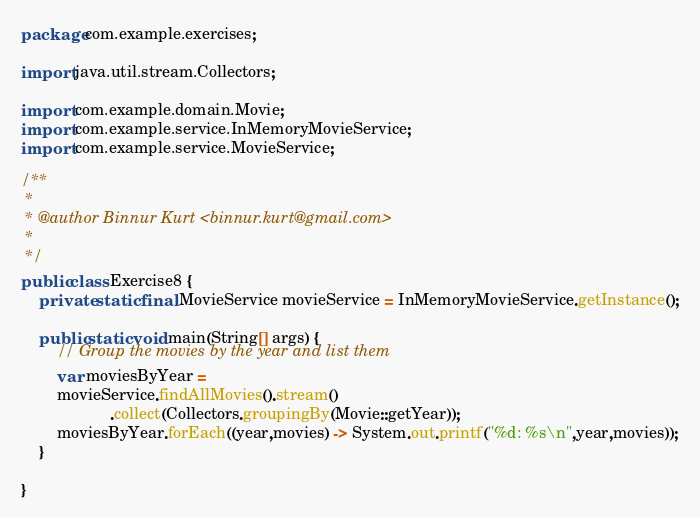<code> <loc_0><loc_0><loc_500><loc_500><_Java_>package com.example.exercises;

import java.util.stream.Collectors;

import com.example.domain.Movie;
import com.example.service.InMemoryMovieService;
import com.example.service.MovieService;

/**
 * 
 * @author Binnur Kurt <binnur.kurt@gmail.com>
 *
 */
public class Exercise8 {
	private static final MovieService movieService = InMemoryMovieService.getInstance();

	public static void main(String[] args) {
		// Group the movies by the year and list them
		var moviesByYear =
		movieService.findAllMovies().stream()
		            .collect(Collectors.groupingBy(Movie::getYear));
		moviesByYear.forEach((year,movies) -> System.out.printf("%d: %s\n",year,movies));
	}

}
</code> 